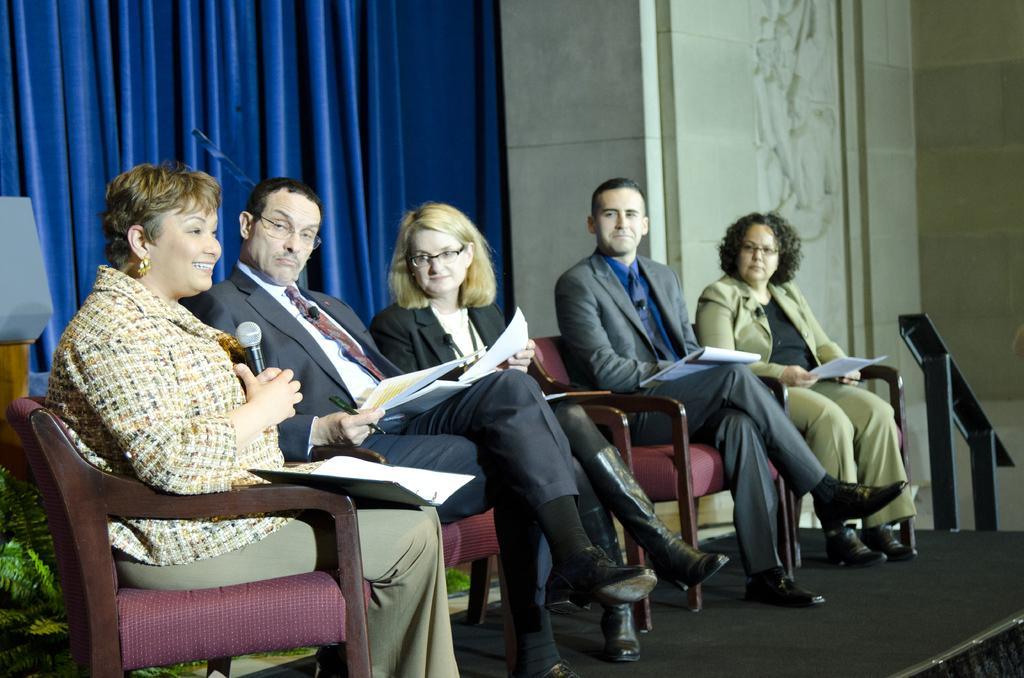Describe this image in one or two sentences. In this image on the left there is a woman she is smiling her hair is short she is sitting on the chair. On the right there is a woman her hair is short she is holding a paper. In the middle there are three people sitting on the chairs and staring at a woman. In the background there is a curtain and wall. 